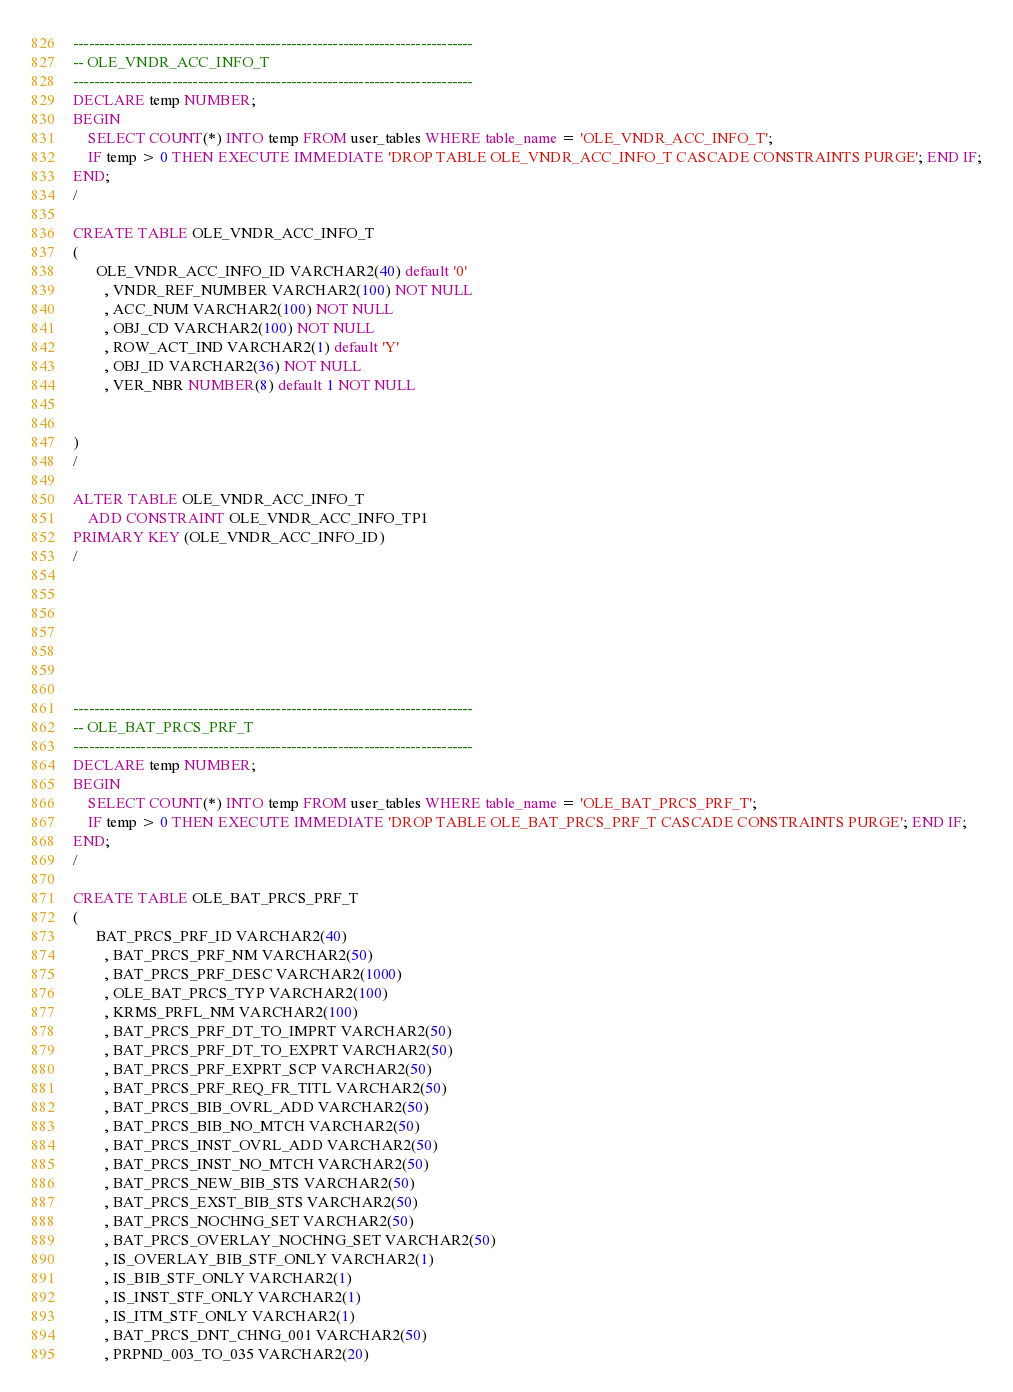<code> <loc_0><loc_0><loc_500><loc_500><_SQL_>




-----------------------------------------------------------------------------
-- OLE_VNDR_ACC_INFO_T
-----------------------------------------------------------------------------
DECLARE temp NUMBER;
BEGIN
	SELECT COUNT(*) INTO temp FROM user_tables WHERE table_name = 'OLE_VNDR_ACC_INFO_T';
	IF temp > 0 THEN EXECUTE IMMEDIATE 'DROP TABLE OLE_VNDR_ACC_INFO_T CASCADE CONSTRAINTS PURGE'; END IF;
END;
/

CREATE TABLE OLE_VNDR_ACC_INFO_T
(
      OLE_VNDR_ACC_INFO_ID VARCHAR2(40) default '0'
        , VNDR_REF_NUMBER VARCHAR2(100) NOT NULL
        , ACC_NUM VARCHAR2(100) NOT NULL
        , OBJ_CD VARCHAR2(100) NOT NULL
        , ROW_ACT_IND VARCHAR2(1) default 'Y'
        , OBJ_ID VARCHAR2(36) NOT NULL
        , VER_NBR NUMBER(8) default 1 NOT NULL
    

)
/

ALTER TABLE OLE_VNDR_ACC_INFO_T
    ADD CONSTRAINT OLE_VNDR_ACC_INFO_TP1
PRIMARY KEY (OLE_VNDR_ACC_INFO_ID)
/







-----------------------------------------------------------------------------
-- OLE_BAT_PRCS_PRF_T
-----------------------------------------------------------------------------
DECLARE temp NUMBER;
BEGIN
	SELECT COUNT(*) INTO temp FROM user_tables WHERE table_name = 'OLE_BAT_PRCS_PRF_T';
	IF temp > 0 THEN EXECUTE IMMEDIATE 'DROP TABLE OLE_BAT_PRCS_PRF_T CASCADE CONSTRAINTS PURGE'; END IF;
END;
/

CREATE TABLE OLE_BAT_PRCS_PRF_T
(
      BAT_PRCS_PRF_ID VARCHAR2(40)
        , BAT_PRCS_PRF_NM VARCHAR2(50)
        , BAT_PRCS_PRF_DESC VARCHAR2(1000)
        , OLE_BAT_PRCS_TYP VARCHAR2(100)
        , KRMS_PRFL_NM VARCHAR2(100)
        , BAT_PRCS_PRF_DT_TO_IMPRT VARCHAR2(50)
        , BAT_PRCS_PRF_DT_TO_EXPRT VARCHAR2(50)
        , BAT_PRCS_PRF_EXPRT_SCP VARCHAR2(50)
        , BAT_PRCS_PRF_REQ_FR_TITL VARCHAR2(50)
        , BAT_PRCS_BIB_OVRL_ADD VARCHAR2(50)
        , BAT_PRCS_BIB_NO_MTCH VARCHAR2(50)
        , BAT_PRCS_INST_OVRL_ADD VARCHAR2(50)
        , BAT_PRCS_INST_NO_MTCH VARCHAR2(50)
        , BAT_PRCS_NEW_BIB_STS VARCHAR2(50)
        , BAT_PRCS_EXST_BIB_STS VARCHAR2(50)
        , BAT_PRCS_NOCHNG_SET VARCHAR2(50)
        , BAT_PRCS_OVERLAY_NOCHNG_SET VARCHAR2(50)
        , IS_OVERLAY_BIB_STF_ONLY VARCHAR2(1)
        , IS_BIB_STF_ONLY VARCHAR2(1)
        , IS_INST_STF_ONLY VARCHAR2(1)
        , IS_ITM_STF_ONLY VARCHAR2(1)
        , BAT_PRCS_DNT_CHNG_001 VARCHAR2(50)
        , PRPND_003_TO_035 VARCHAR2(20)</code> 